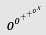Convert formula to latex. <formula><loc_0><loc_0><loc_500><loc_500>o ^ { o ^ { + ^ { + ^ { o ^ { x } } } } }</formula> 